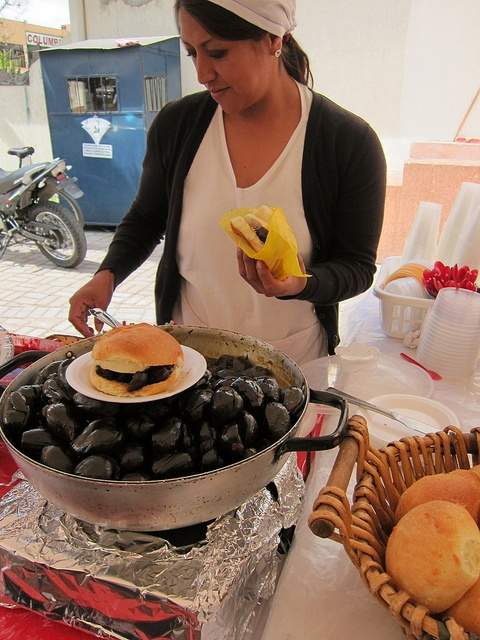Describe the objects in this image and their specific colors. I can see people in ivory, black, tan, brown, and maroon tones, dining table in white, tan, and gray tones, motorcycle in ivory, gray, darkgray, black, and lightgray tones, sandwich in ivory, red, tan, and black tones, and cup in white, darkgray, tan, and brown tones in this image. 